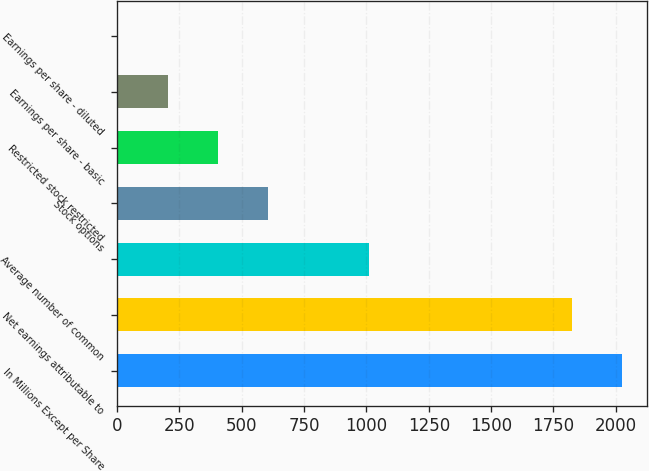Convert chart. <chart><loc_0><loc_0><loc_500><loc_500><bar_chart><fcel>In Millions Except per Share<fcel>Net earnings attributable to<fcel>Average number of common<fcel>Stock options<fcel>Restricted stock restricted<fcel>Earnings per share - basic<fcel>Earnings per share - diluted<nl><fcel>2025.52<fcel>1824.4<fcel>1008.43<fcel>606.19<fcel>405.07<fcel>203.95<fcel>2.83<nl></chart> 